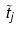Convert formula to latex. <formula><loc_0><loc_0><loc_500><loc_500>\tilde { t } _ { j }</formula> 